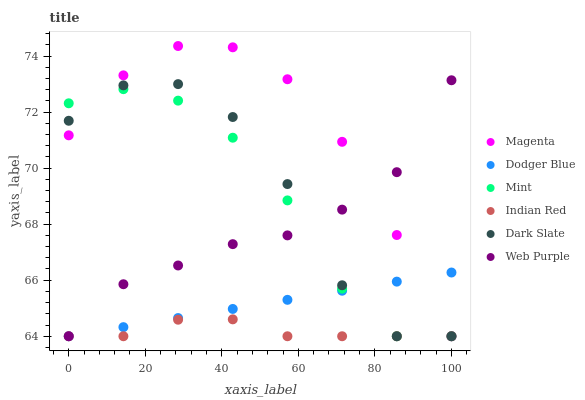Does Indian Red have the minimum area under the curve?
Answer yes or no. Yes. Does Magenta have the maximum area under the curve?
Answer yes or no. Yes. Does Web Purple have the minimum area under the curve?
Answer yes or no. No. Does Web Purple have the maximum area under the curve?
Answer yes or no. No. Is Dodger Blue the smoothest?
Answer yes or no. Yes. Is Dark Slate the roughest?
Answer yes or no. Yes. Is Web Purple the smoothest?
Answer yes or no. No. Is Web Purple the roughest?
Answer yes or no. No. Does Dark Slate have the lowest value?
Answer yes or no. Yes. Does Magenta have the highest value?
Answer yes or no. Yes. Does Web Purple have the highest value?
Answer yes or no. No. Does Web Purple intersect Dodger Blue?
Answer yes or no. Yes. Is Web Purple less than Dodger Blue?
Answer yes or no. No. Is Web Purple greater than Dodger Blue?
Answer yes or no. No. 